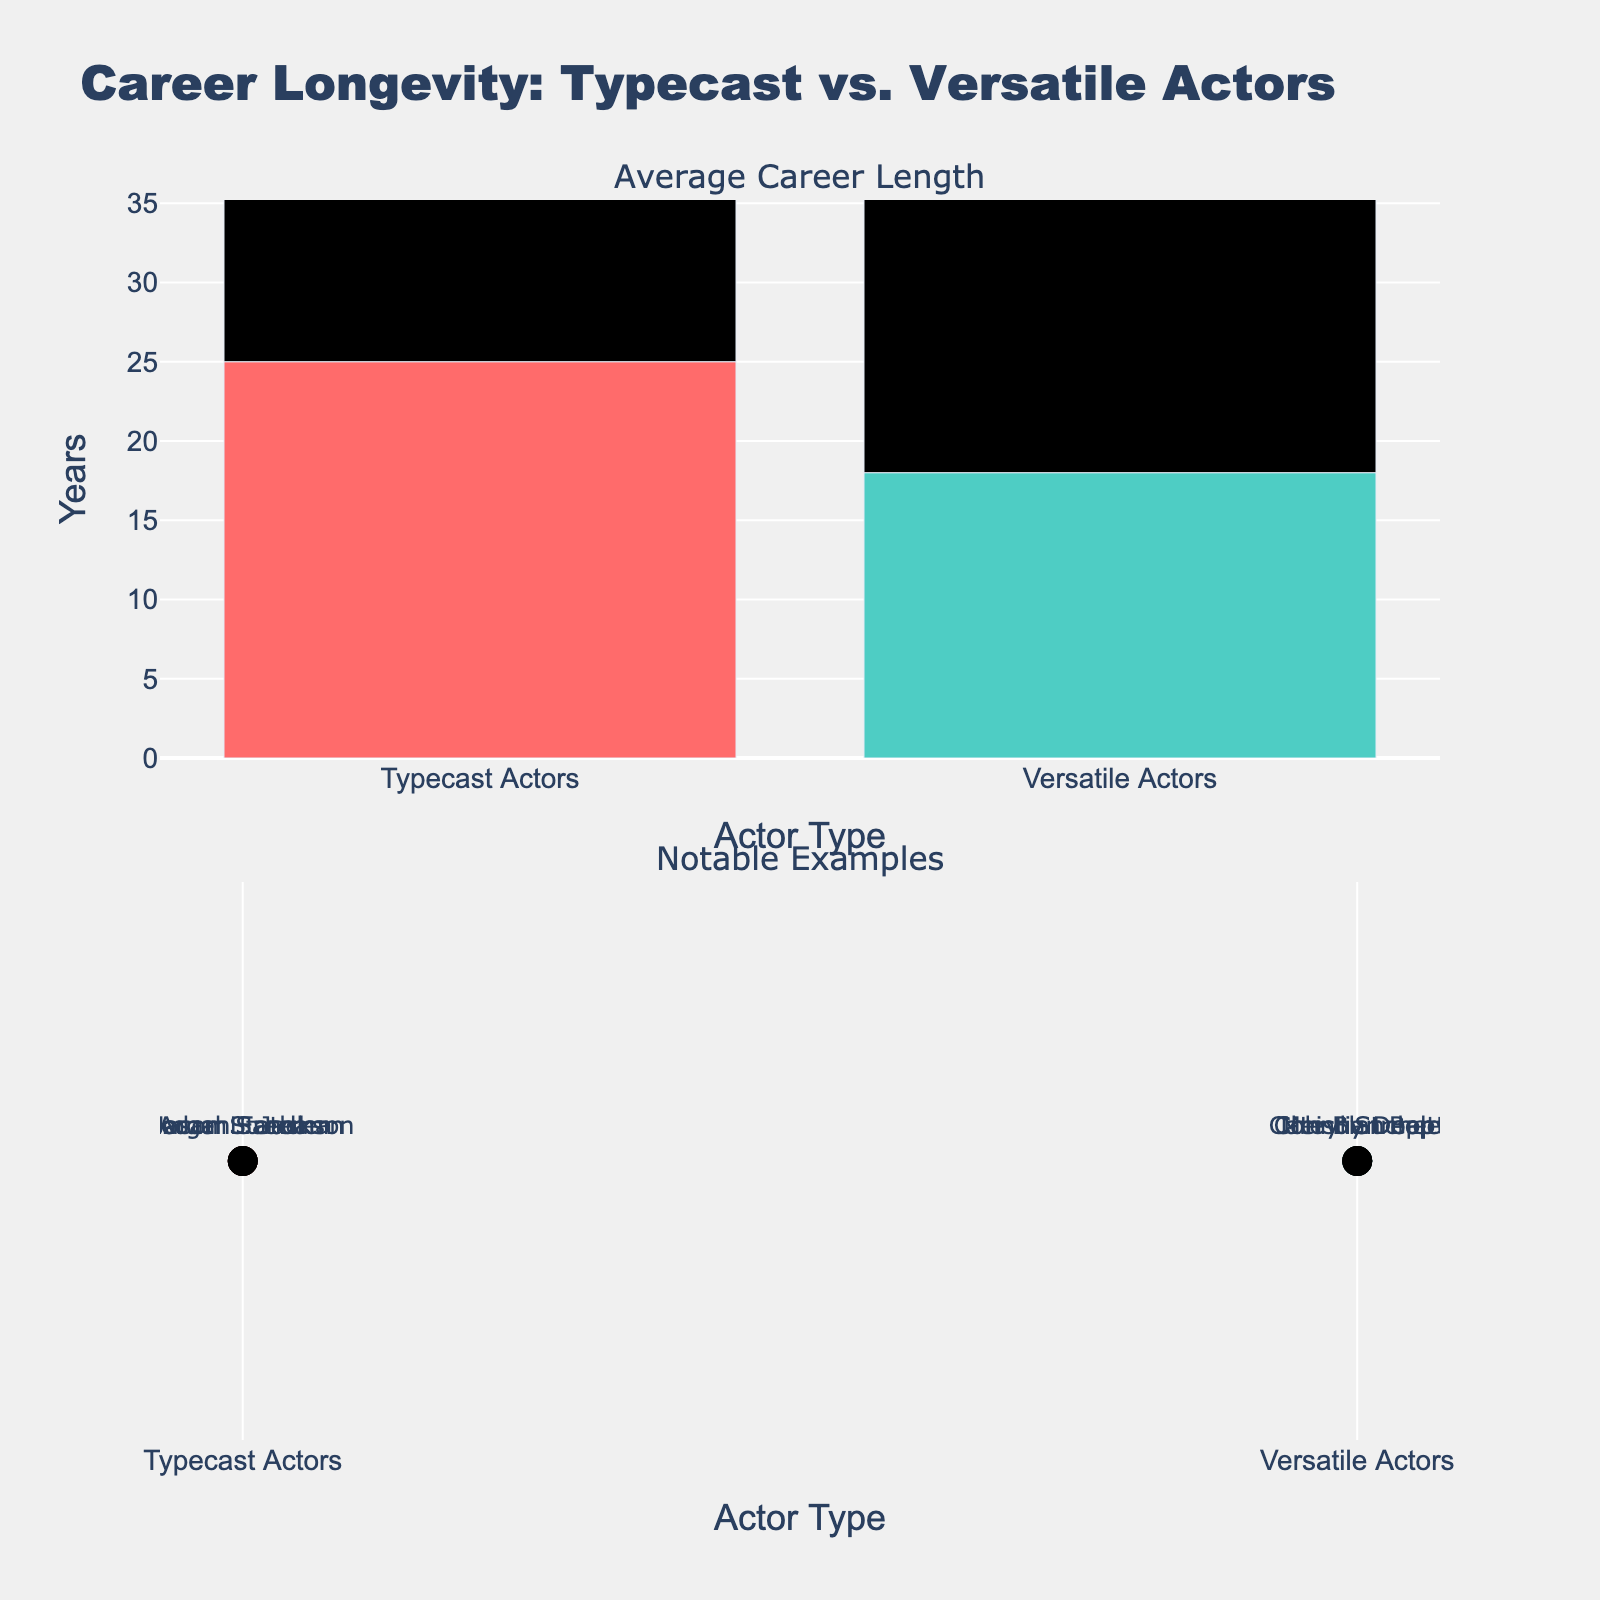What is the title of the figure? The title is located at the top of the figure.
Answer: Career Longevity: Typecast vs. Versatile Actors What is the average career length (years) for typecast actors based on the bar chart? Refer to the values displayed on the bar chart for typecast actors.
Answer: 28.75 years Which actor type has a larger average career length, typecast or versatile actors? Compare the heights of bars for both types of actors in the top subplot.
Answer: Typecast Actors What is the total sum of average career lengths for versatile actors? The average career lengths for versatile actors are given; sum them up: 18 + 22 + 20 + 24.
Answer: 84 years Who is a notable example of a versatile actor whose career length is shown in the scatter plot? Look at the text labels in the second subplot for versatile actors.
Answer: Johnny Depp, Meryl Streep, Christian Bale, Cate Blanchett What is the difference in average career length between typecast and versatile actors? Calculate the difference by subtracting the average career lengths: 28.75 for typecast actors and 21 for versatile actors.
Answer: 7.75 years Which notable example of a typecast actor has the longest average career length? Compare the values associated with each typecast actor's name in the scatter plot.
Answer: Samuel L. Jackson Based on the bar chart, how does the career longevity of Adam Sandler compare to that of Meryl Streep on the scatter plot? Refer to Adam Sandler's career length under typecast actors and Meryl Streep's under versatile actors in their respective subplots.
Answer: Adam Sandler (28 years) vs. Meryl Streep (22 years) What is the range of years for the average career lengths shown for typecast actors? Identify the minimum and maximum years for typecast actors: 25 (Jason Statham) to 32 (Samuel L. Jackson).
Answer: 7 years Considering both subplots, what notable trend can you infer about the career length of typecast versus versatile actors? Synthesize information from both subplots to make an inference about the actors' career lengths.
Answer: Typecast actors generally have longer average careers than versatile actors 